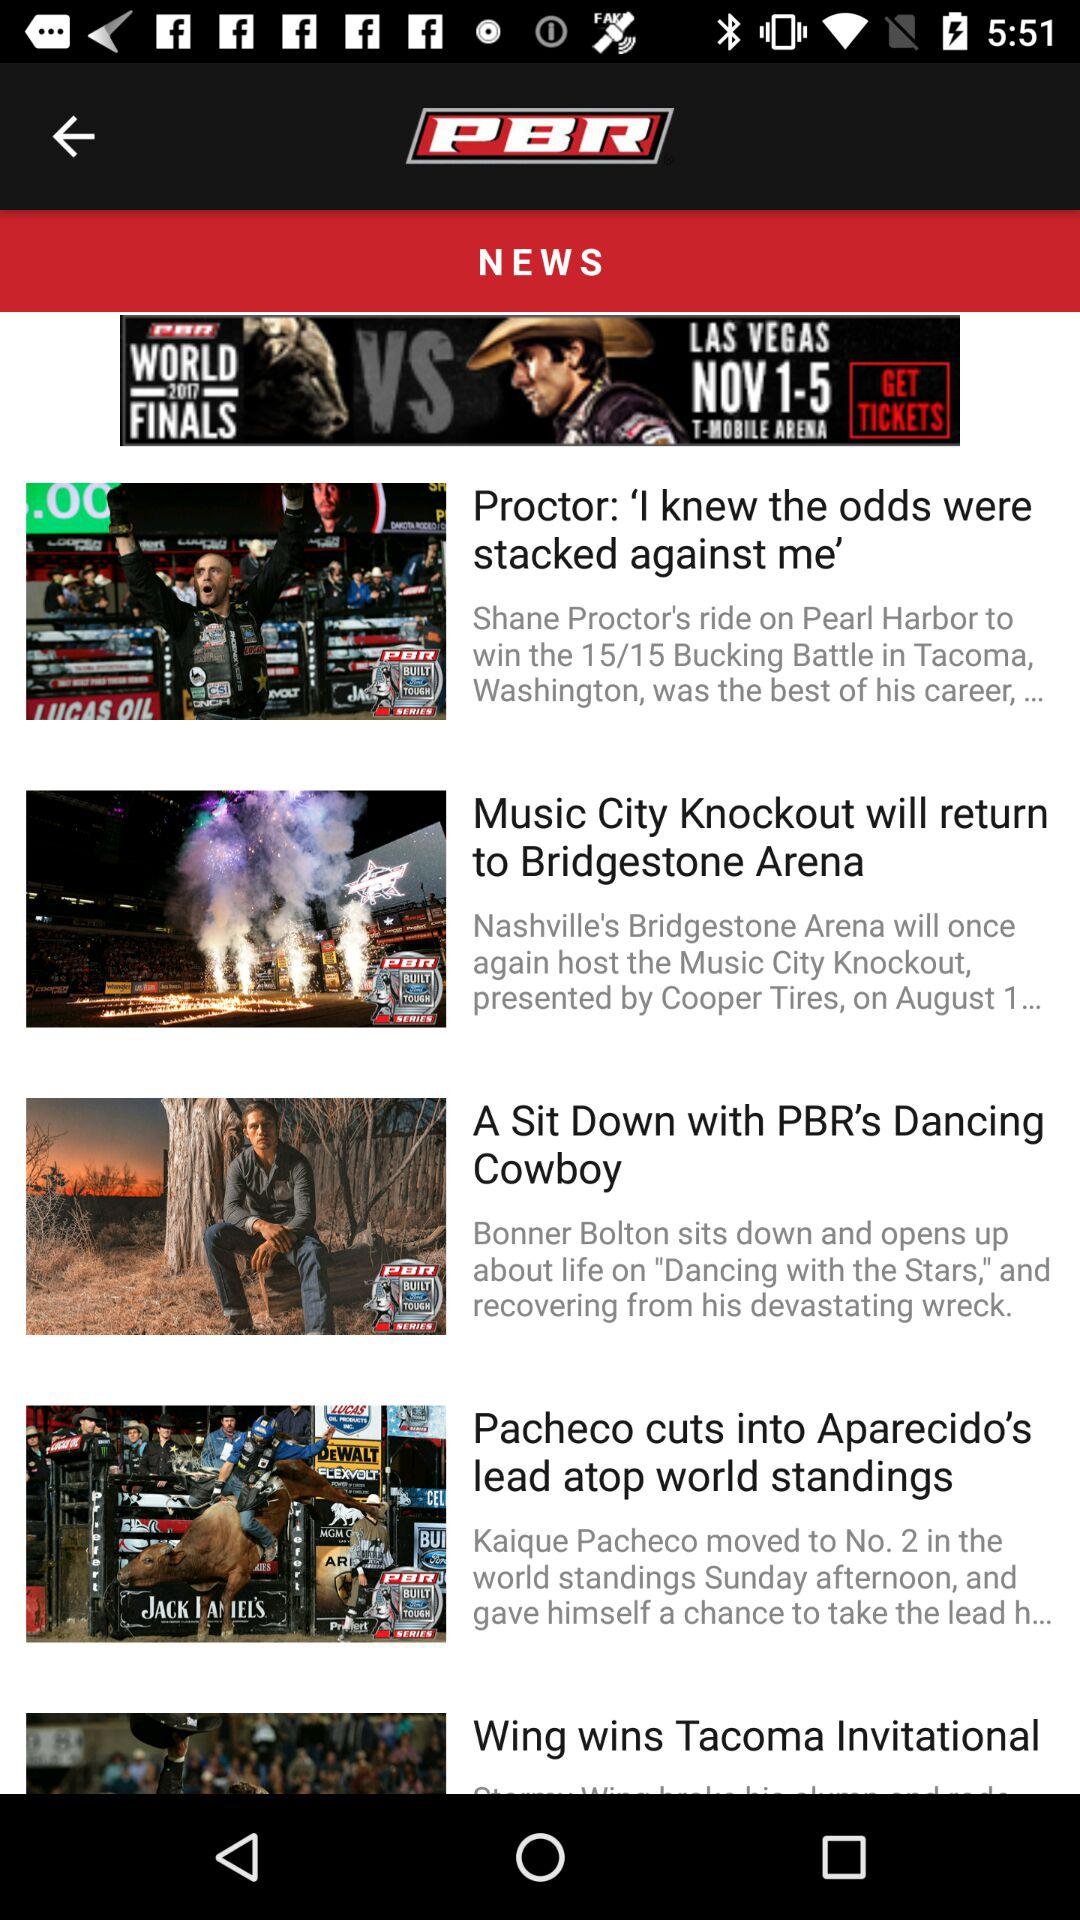How many stories are there in the news section?
Answer the question using a single word or phrase. 5 